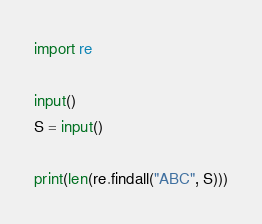<code> <loc_0><loc_0><loc_500><loc_500><_Python_>import re

input()
S = input()

print(len(re.findall("ABC", S)))</code> 